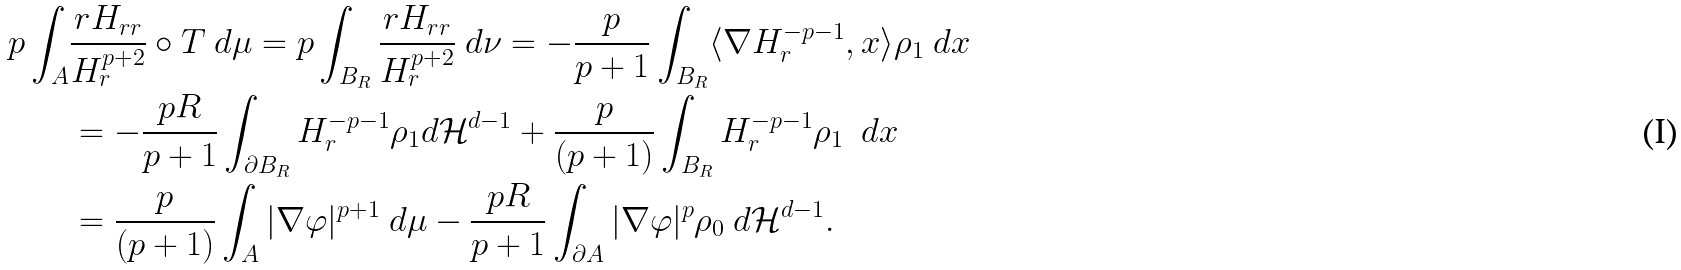Convert formula to latex. <formula><loc_0><loc_0><loc_500><loc_500>p \int _ { A } & \frac { r H _ { r r } } { H ^ { p + 2 } _ { r } } \circ T \ d \mu = p \int _ { B _ { R } } \frac { r H _ { r r } } { H ^ { p + 2 } _ { r } } \ d \nu = - \frac { p } { p + 1 } \int _ { B _ { R } } \langle \nabla H ^ { - p - 1 } _ { r } , x \rangle \rho _ { 1 } \ d x \\ & = - \frac { p R } { p + 1 } \int _ { \partial B _ { R } } H ^ { - p - 1 } _ { r } \rho _ { 1 } d \mathcal { H } ^ { d - 1 } + \frac { p } { ( p + 1 ) } \int _ { B _ { R } } H ^ { - p - 1 } _ { r } \rho _ { 1 } \ \ d x \\ & = \frac { p } { ( p + 1 ) } \int _ { A } | \nabla \varphi | ^ { p + 1 } \ d \mu - \frac { p R } { p + 1 } \int _ { \partial A } | \nabla \varphi | ^ { p } \rho _ { 0 } \ d \mathcal { H } ^ { d - 1 } .</formula> 